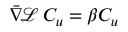Convert formula to latex. <formula><loc_0><loc_0><loc_500><loc_500>{ \bar { \nabla } } \, { \mathcal { L } } \, C _ { u } = \beta C _ { u }</formula> 